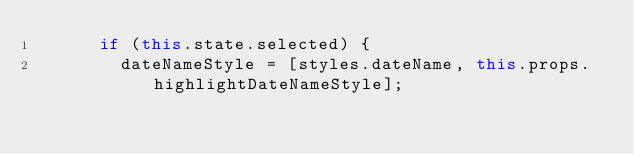<code> <loc_0><loc_0><loc_500><loc_500><_JavaScript_>      if (this.state.selected) {
        dateNameStyle = [styles.dateName, this.props.highlightDateNameStyle];</code> 